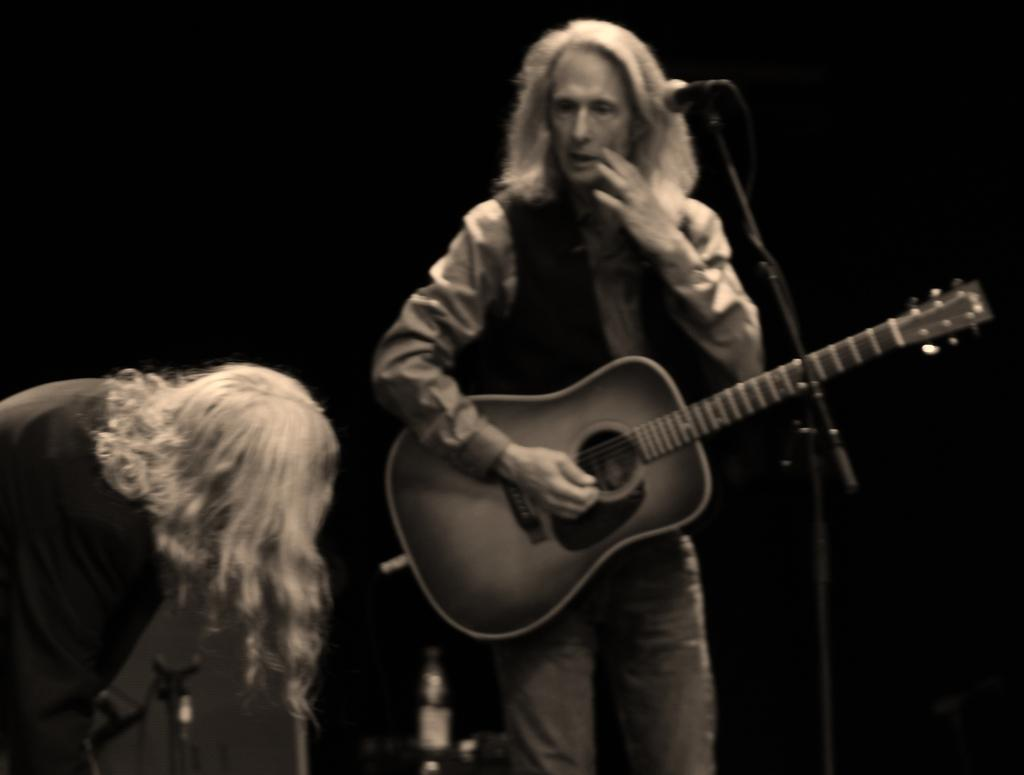What is the man in the image holding? The man is holding a guitar. What object is in front of the man? There is a mic in front of the man. Who else is present in the image? There is a woman in the image. What is the woman doing in the image? The woman is bent and looking at the man. What type of good-bye message is the man singing to the woman in the image? There is no indication in the image that the man is singing a good-bye message to the woman. What effect does the music have on the government in the image? There is no reference to the government or any effects on it in the image. 